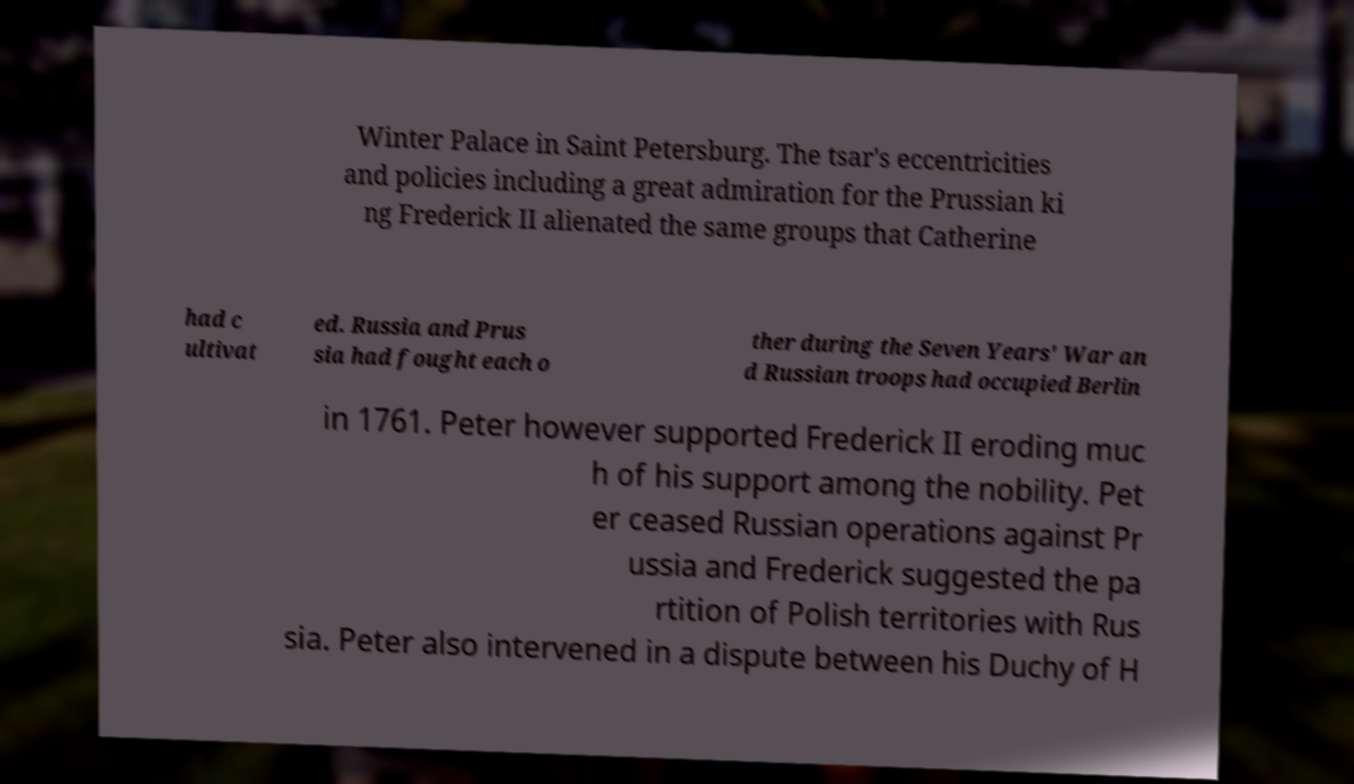Please identify and transcribe the text found in this image. Winter Palace in Saint Petersburg. The tsar's eccentricities and policies including a great admiration for the Prussian ki ng Frederick II alienated the same groups that Catherine had c ultivat ed. Russia and Prus sia had fought each o ther during the Seven Years' War an d Russian troops had occupied Berlin in 1761. Peter however supported Frederick II eroding muc h of his support among the nobility. Pet er ceased Russian operations against Pr ussia and Frederick suggested the pa rtition of Polish territories with Rus sia. Peter also intervened in a dispute between his Duchy of H 